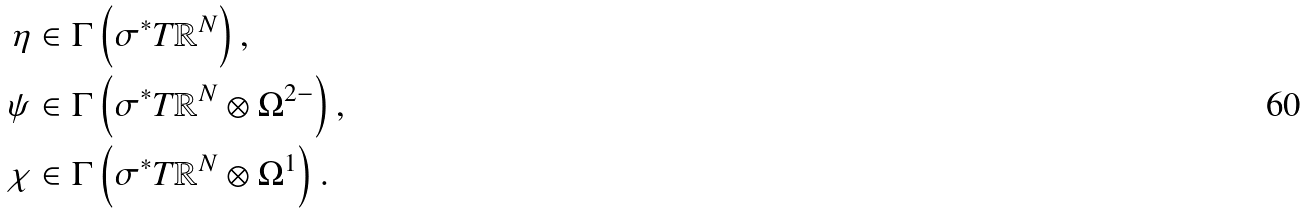Convert formula to latex. <formula><loc_0><loc_0><loc_500><loc_500>\eta & \in \Gamma \left ( \sigma ^ { * } T \mathbb { R } ^ { N } \right ) , \\ \psi & \in \Gamma \left ( \sigma ^ { * } T \mathbb { R } ^ { N } \otimes \Omega ^ { 2 - } \right ) , \\ \chi & \in \Gamma \left ( \sigma ^ { * } T \mathbb { R } ^ { N } \otimes \Omega ^ { 1 } \right ) . \\</formula> 